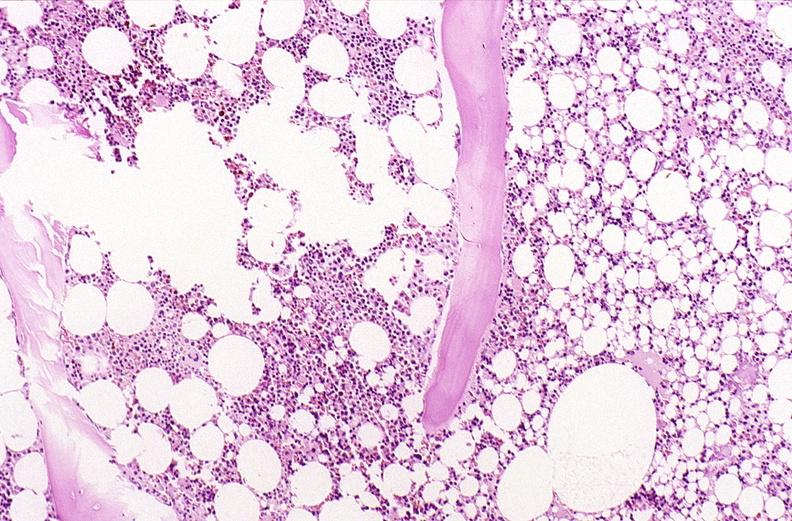s malignant thymoma present?
Answer the question using a single word or phrase. No 